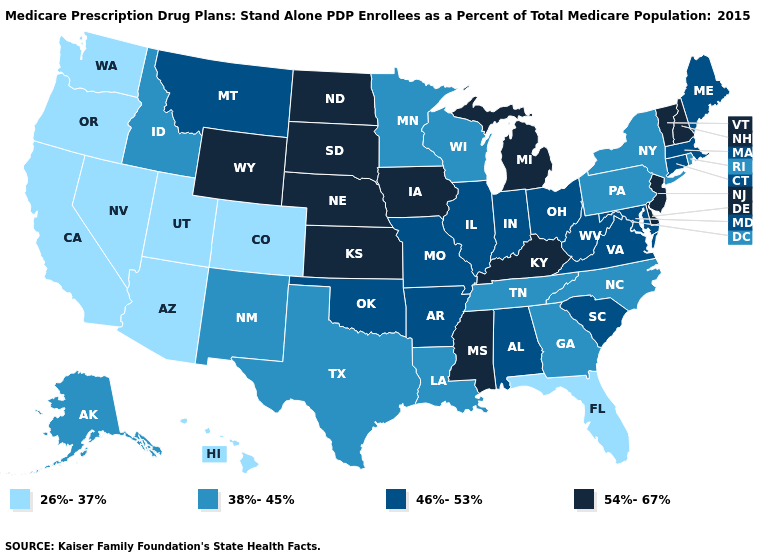Does Nevada have the lowest value in the West?
Keep it brief. Yes. Name the states that have a value in the range 38%-45%?
Write a very short answer. Alaska, Georgia, Idaho, Louisiana, Minnesota, North Carolina, New Mexico, New York, Pennsylvania, Rhode Island, Tennessee, Texas, Wisconsin. What is the value of Virginia?
Give a very brief answer. 46%-53%. What is the value of Massachusetts?
Answer briefly. 46%-53%. Name the states that have a value in the range 46%-53%?
Write a very short answer. Alabama, Arkansas, Connecticut, Illinois, Indiana, Massachusetts, Maryland, Maine, Missouri, Montana, Ohio, Oklahoma, South Carolina, Virginia, West Virginia. Does the map have missing data?
Keep it brief. No. Does Illinois have the lowest value in the USA?
Concise answer only. No. Among the states that border Illinois , does Wisconsin have the highest value?
Concise answer only. No. What is the value of Montana?
Short answer required. 46%-53%. Which states have the highest value in the USA?
Quick response, please. Delaware, Iowa, Kansas, Kentucky, Michigan, Mississippi, North Dakota, Nebraska, New Hampshire, New Jersey, South Dakota, Vermont, Wyoming. Name the states that have a value in the range 46%-53%?
Be succinct. Alabama, Arkansas, Connecticut, Illinois, Indiana, Massachusetts, Maryland, Maine, Missouri, Montana, Ohio, Oklahoma, South Carolina, Virginia, West Virginia. Name the states that have a value in the range 38%-45%?
Give a very brief answer. Alaska, Georgia, Idaho, Louisiana, Minnesota, North Carolina, New Mexico, New York, Pennsylvania, Rhode Island, Tennessee, Texas, Wisconsin. What is the value of Arizona?
Write a very short answer. 26%-37%. What is the value of Alaska?
Write a very short answer. 38%-45%. 